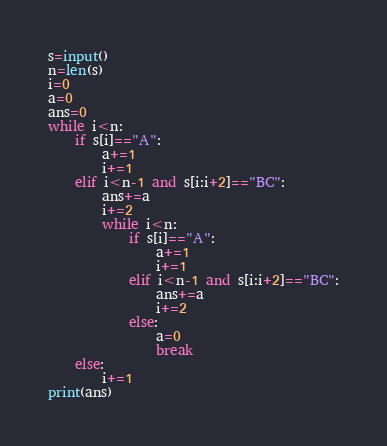Convert code to text. <code><loc_0><loc_0><loc_500><loc_500><_Python_>s=input()
n=len(s)
i=0
a=0
ans=0
while i<n:
    if s[i]=="A":
        a+=1
        i+=1
    elif i<n-1 and s[i:i+2]=="BC":
        ans+=a
        i+=2
        while i<n:
            if s[i]=="A":
                a+=1
                i+=1
            elif i<n-1 and s[i:i+2]=="BC":
                ans+=a
                i+=2
            else:
                a=0
                break
    else:
        i+=1
print(ans)</code> 